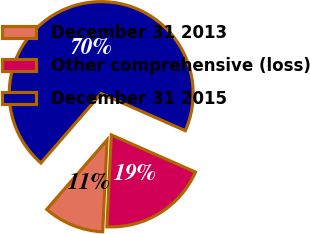<chart> <loc_0><loc_0><loc_500><loc_500><pie_chart><fcel>December 31 2013<fcel>Other comprehensive (loss)<fcel>December 31 2015<nl><fcel>10.62%<fcel>19.15%<fcel>70.23%<nl></chart> 